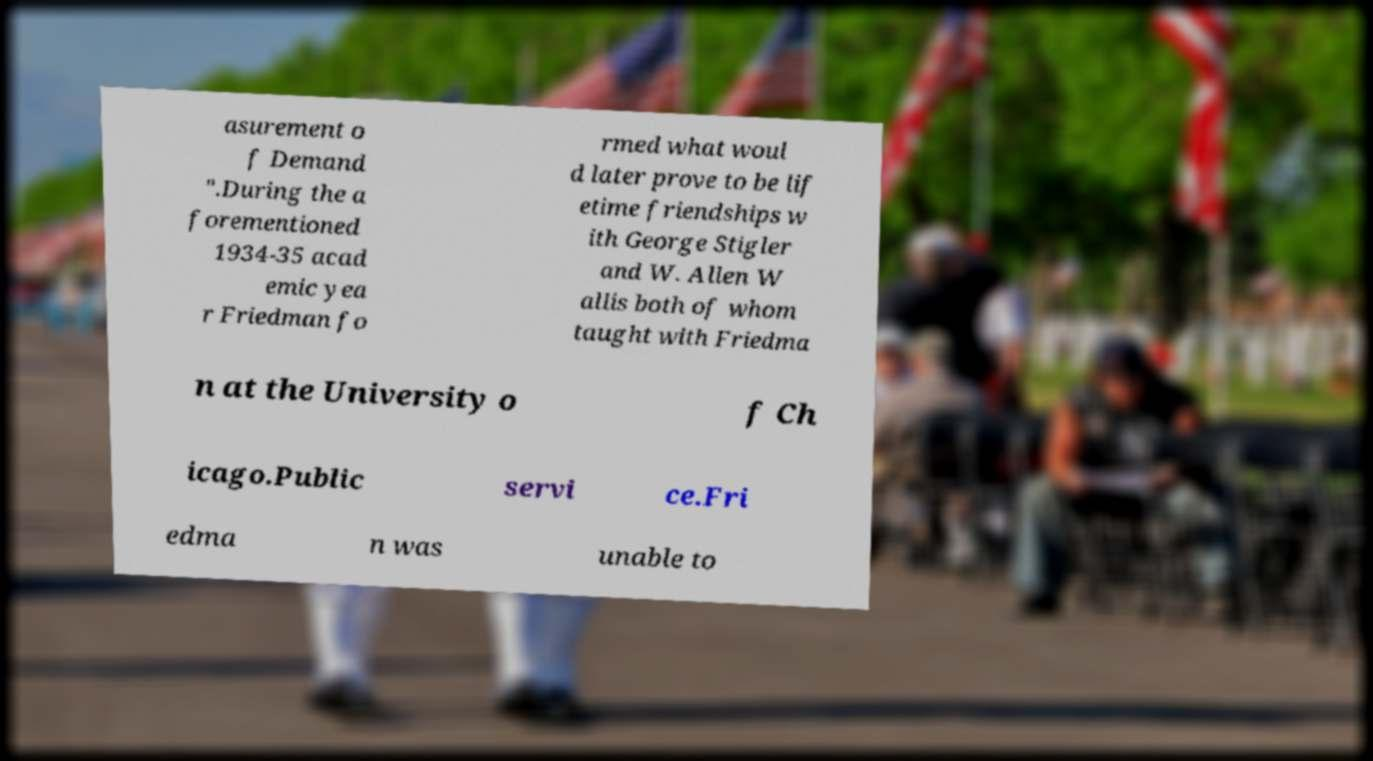Could you extract and type out the text from this image? asurement o f Demand ".During the a forementioned 1934-35 acad emic yea r Friedman fo rmed what woul d later prove to be lif etime friendships w ith George Stigler and W. Allen W allis both of whom taught with Friedma n at the University o f Ch icago.Public servi ce.Fri edma n was unable to 